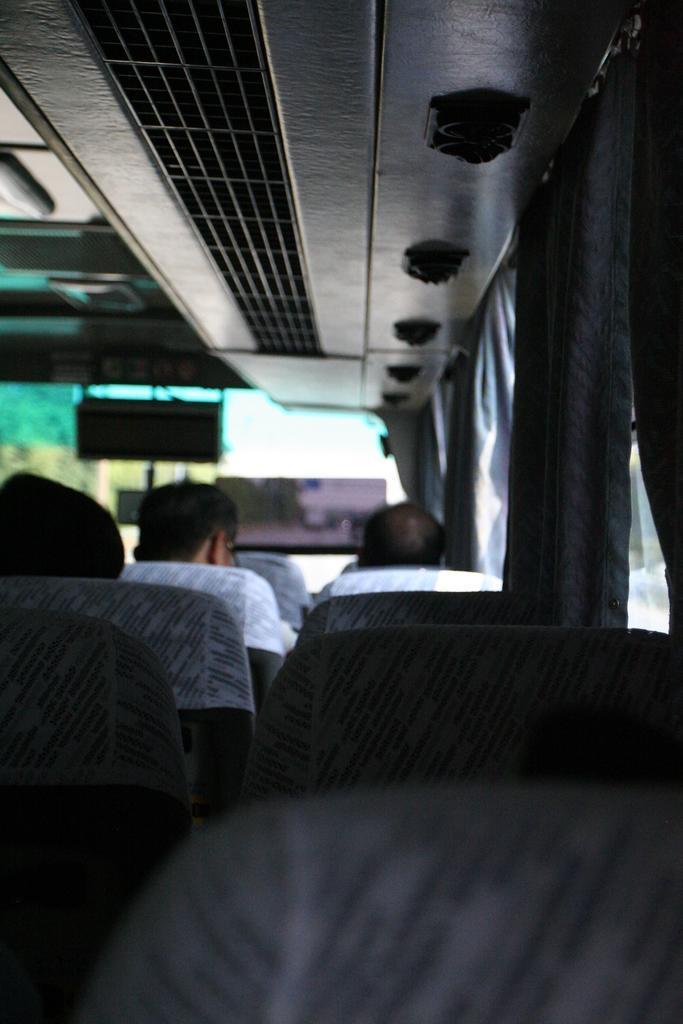In one or two sentences, can you explain what this image depicts? Here in this picture we can see some people sitting on the bus seats and we can see the AC ducts present at the top and we can see window curtains present over there. 